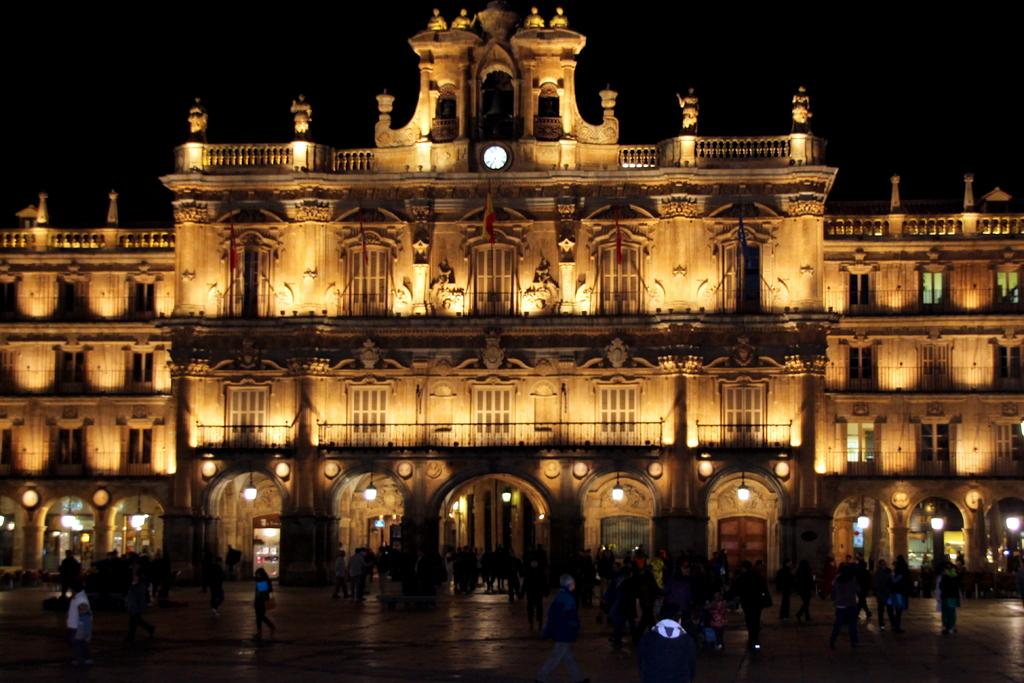What type of structure is visible in the image? There is a building in the image. What can be seen illuminating the scene in the image? There are lights in the image. Is there any indication of time in the image? Yes, there is a clock in the image. What is happening at the bottom of the image? There are people on the road at the bottom of the image. What is visible at the top of the image? The sky is visible at the top of the image. What type of fork can be seen in the image? There is no fork present in the image. How much money is being exchanged between the people on the road in the image? There is no indication of money being exchanged between the people on the road in the image. 